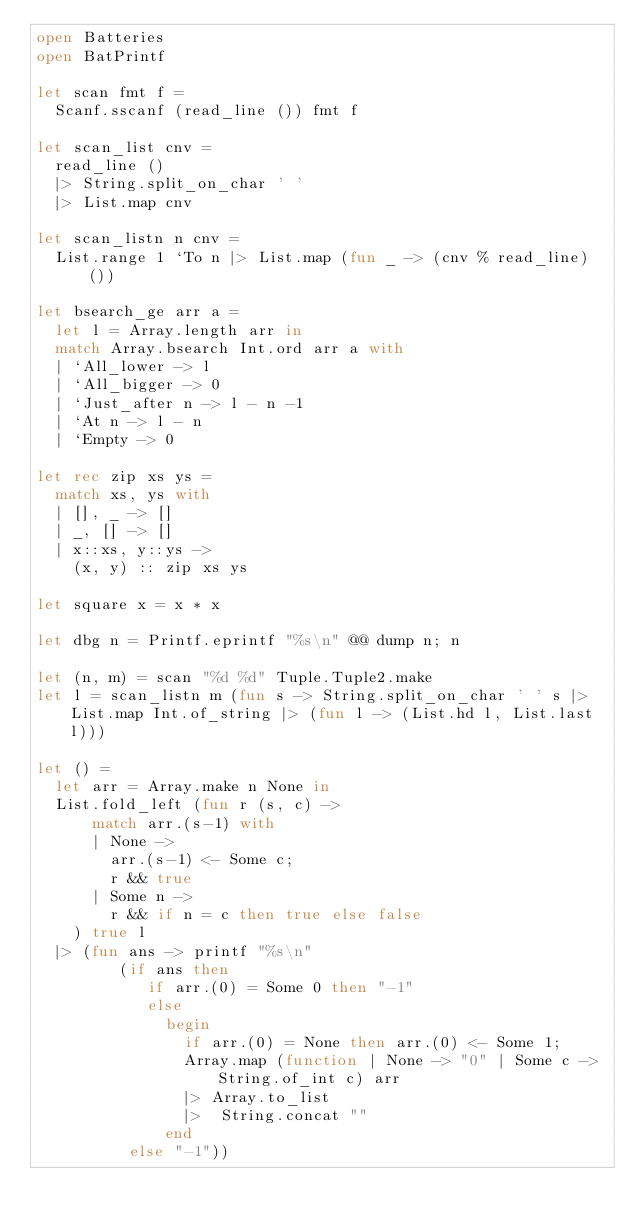<code> <loc_0><loc_0><loc_500><loc_500><_OCaml_>open Batteries
open BatPrintf

let scan fmt f =
  Scanf.sscanf (read_line ()) fmt f

let scan_list cnv =
  read_line ()
  |> String.split_on_char ' '
  |> List.map cnv

let scan_listn n cnv =
  List.range 1 `To n |> List.map (fun _ -> (cnv % read_line) ())

let bsearch_ge arr a =
  let l = Array.length arr in
  match Array.bsearch Int.ord arr a with
  | `All_lower -> l
  | `All_bigger -> 0
  | `Just_after n -> l - n -1
  | `At n -> l - n
  | `Empty -> 0

let rec zip xs ys =
  match xs, ys with
  | [], _ -> []
  | _, [] -> []
  | x::xs, y::ys ->
    (x, y) :: zip xs ys

let square x = x * x

let dbg n = Printf.eprintf "%s\n" @@ dump n; n

let (n, m) = scan "%d %d" Tuple.Tuple2.make
let l = scan_listn m (fun s -> String.split_on_char ' ' s |> List.map Int.of_string |> (fun l -> (List.hd l, List.last l)))

let () =
  let arr = Array.make n None in
  List.fold_left (fun r (s, c) ->
      match arr.(s-1) with
      | None ->
        arr.(s-1) <- Some c;
        r && true
      | Some n ->
        r && if n = c then true else false
    ) true l
  |> (fun ans -> printf "%s\n"
         (if ans then
            if arr.(0) = Some 0 then "-1"
            else
              begin
                if arr.(0) = None then arr.(0) <- Some 1;
                Array.map (function | None -> "0" | Some c -> String.of_int c) arr
                |> Array.to_list
                |>  String.concat ""
              end
          else "-1"))
</code> 